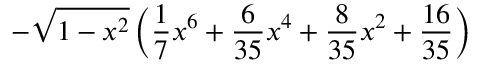<formula> <loc_0><loc_0><loc_500><loc_500>- \sqrt { 1 - x ^ { 2 } } \left ( \frac { 1 } { 7 } x ^ { 6 } + \frac { 6 } { 3 5 } x ^ { 4 } + \frac { 8 } { 3 5 } x ^ { 2 } + \frac { 1 6 } { 3 5 } \right )</formula> 